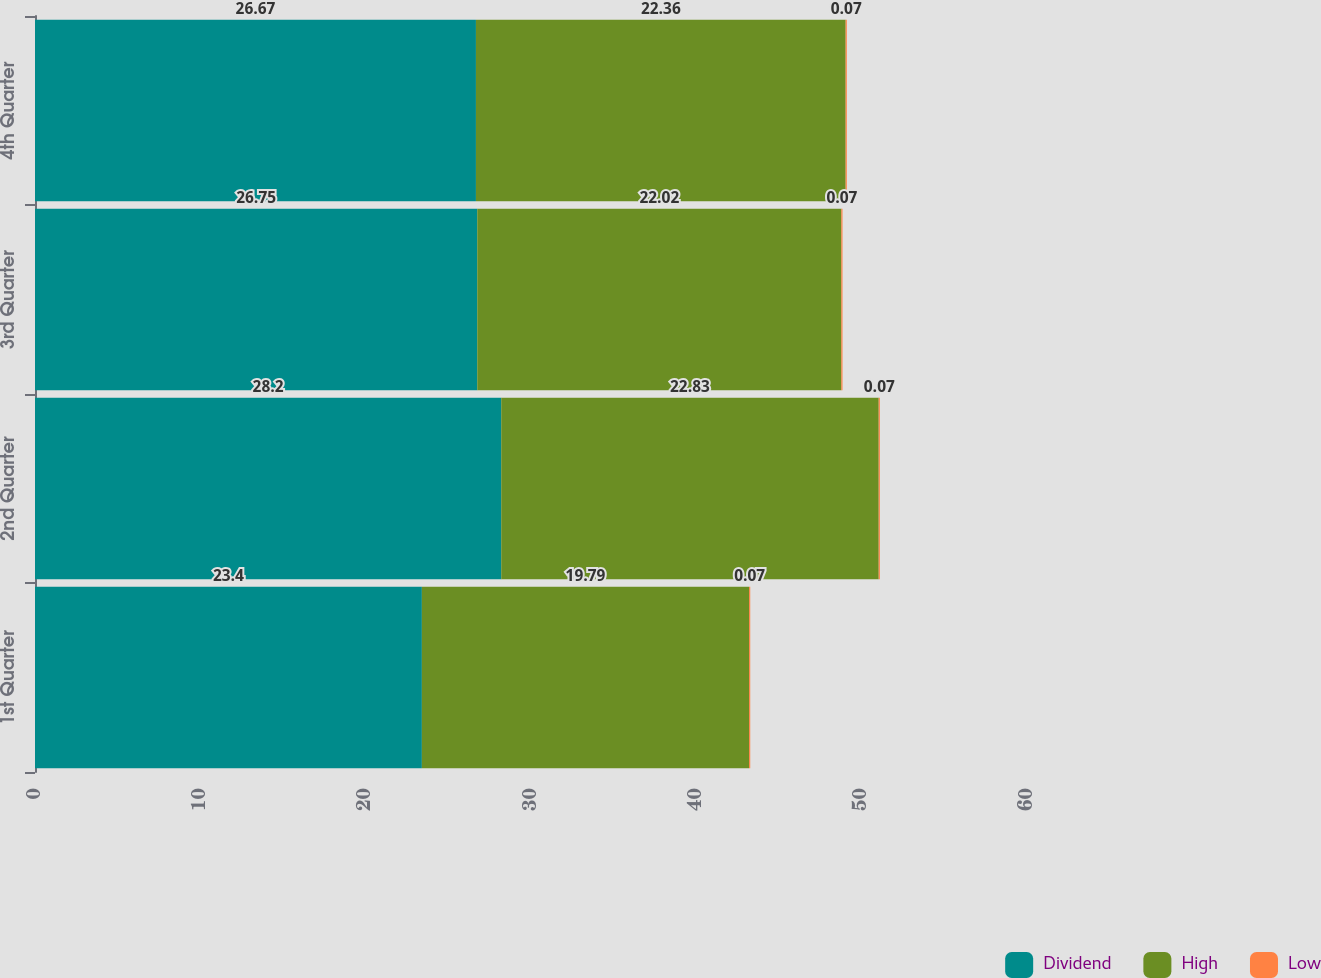Convert chart. <chart><loc_0><loc_0><loc_500><loc_500><stacked_bar_chart><ecel><fcel>1st Quarter<fcel>2nd Quarter<fcel>3rd Quarter<fcel>4th Quarter<nl><fcel>Dividend<fcel>23.4<fcel>28.2<fcel>26.75<fcel>26.67<nl><fcel>High<fcel>19.79<fcel>22.83<fcel>22.02<fcel>22.36<nl><fcel>Low<fcel>0.07<fcel>0.07<fcel>0.07<fcel>0.07<nl></chart> 